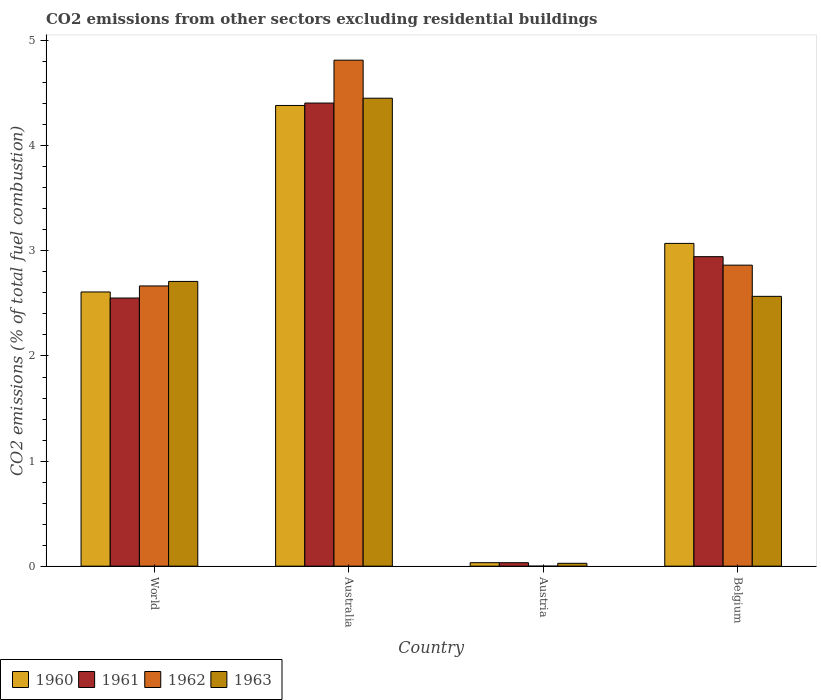Are the number of bars per tick equal to the number of legend labels?
Offer a very short reply. No. How many bars are there on the 3rd tick from the right?
Provide a succinct answer. 4. What is the total CO2 emitted in 1961 in Belgium?
Offer a very short reply. 2.95. Across all countries, what is the maximum total CO2 emitted in 1961?
Ensure brevity in your answer.  4.41. What is the total total CO2 emitted in 1961 in the graph?
Keep it short and to the point. 9.94. What is the difference between the total CO2 emitted in 1960 in Austria and that in Belgium?
Provide a succinct answer. -3.04. What is the difference between the total CO2 emitted in 1963 in World and the total CO2 emitted in 1961 in Belgium?
Offer a very short reply. -0.24. What is the average total CO2 emitted in 1963 per country?
Offer a terse response. 2.44. What is the difference between the total CO2 emitted of/in 1963 and total CO2 emitted of/in 1960 in Belgium?
Ensure brevity in your answer.  -0.5. In how many countries, is the total CO2 emitted in 1963 greater than 4.8?
Make the answer very short. 0. What is the ratio of the total CO2 emitted in 1961 in Australia to that in Austria?
Your answer should be very brief. 133.62. Is the total CO2 emitted in 1960 in Belgium less than that in World?
Your answer should be compact. No. What is the difference between the highest and the second highest total CO2 emitted in 1960?
Provide a succinct answer. -0.46. What is the difference between the highest and the lowest total CO2 emitted in 1962?
Keep it short and to the point. 4.82. How many bars are there?
Your answer should be compact. 15. Are all the bars in the graph horizontal?
Offer a very short reply. No. Are the values on the major ticks of Y-axis written in scientific E-notation?
Offer a terse response. No. Does the graph contain grids?
Offer a terse response. No. How many legend labels are there?
Your response must be concise. 4. What is the title of the graph?
Offer a very short reply. CO2 emissions from other sectors excluding residential buildings. What is the label or title of the Y-axis?
Provide a short and direct response. CO2 emissions (% of total fuel combustion). What is the CO2 emissions (% of total fuel combustion) in 1960 in World?
Provide a succinct answer. 2.61. What is the CO2 emissions (% of total fuel combustion) in 1961 in World?
Keep it short and to the point. 2.55. What is the CO2 emissions (% of total fuel combustion) of 1962 in World?
Keep it short and to the point. 2.67. What is the CO2 emissions (% of total fuel combustion) in 1963 in World?
Your answer should be very brief. 2.71. What is the CO2 emissions (% of total fuel combustion) in 1960 in Australia?
Offer a terse response. 4.38. What is the CO2 emissions (% of total fuel combustion) in 1961 in Australia?
Your response must be concise. 4.41. What is the CO2 emissions (% of total fuel combustion) of 1962 in Australia?
Keep it short and to the point. 4.82. What is the CO2 emissions (% of total fuel combustion) in 1963 in Australia?
Your answer should be very brief. 4.45. What is the CO2 emissions (% of total fuel combustion) in 1960 in Austria?
Offer a terse response. 0.03. What is the CO2 emissions (% of total fuel combustion) of 1961 in Austria?
Offer a very short reply. 0.03. What is the CO2 emissions (% of total fuel combustion) of 1962 in Austria?
Your response must be concise. 0. What is the CO2 emissions (% of total fuel combustion) of 1963 in Austria?
Your response must be concise. 0.03. What is the CO2 emissions (% of total fuel combustion) of 1960 in Belgium?
Your answer should be compact. 3.07. What is the CO2 emissions (% of total fuel combustion) of 1961 in Belgium?
Offer a very short reply. 2.95. What is the CO2 emissions (% of total fuel combustion) of 1962 in Belgium?
Provide a succinct answer. 2.86. What is the CO2 emissions (% of total fuel combustion) of 1963 in Belgium?
Your response must be concise. 2.57. Across all countries, what is the maximum CO2 emissions (% of total fuel combustion) in 1960?
Ensure brevity in your answer.  4.38. Across all countries, what is the maximum CO2 emissions (% of total fuel combustion) of 1961?
Make the answer very short. 4.41. Across all countries, what is the maximum CO2 emissions (% of total fuel combustion) in 1962?
Provide a succinct answer. 4.82. Across all countries, what is the maximum CO2 emissions (% of total fuel combustion) in 1963?
Offer a terse response. 4.45. Across all countries, what is the minimum CO2 emissions (% of total fuel combustion) of 1960?
Your answer should be very brief. 0.03. Across all countries, what is the minimum CO2 emissions (% of total fuel combustion) in 1961?
Keep it short and to the point. 0.03. Across all countries, what is the minimum CO2 emissions (% of total fuel combustion) in 1962?
Make the answer very short. 0. Across all countries, what is the minimum CO2 emissions (% of total fuel combustion) of 1963?
Make the answer very short. 0.03. What is the total CO2 emissions (% of total fuel combustion) in 1960 in the graph?
Your response must be concise. 10.1. What is the total CO2 emissions (% of total fuel combustion) in 1961 in the graph?
Provide a short and direct response. 9.94. What is the total CO2 emissions (% of total fuel combustion) in 1962 in the graph?
Keep it short and to the point. 10.35. What is the total CO2 emissions (% of total fuel combustion) of 1963 in the graph?
Make the answer very short. 9.76. What is the difference between the CO2 emissions (% of total fuel combustion) of 1960 in World and that in Australia?
Ensure brevity in your answer.  -1.77. What is the difference between the CO2 emissions (% of total fuel combustion) of 1961 in World and that in Australia?
Your response must be concise. -1.86. What is the difference between the CO2 emissions (% of total fuel combustion) in 1962 in World and that in Australia?
Provide a succinct answer. -2.15. What is the difference between the CO2 emissions (% of total fuel combustion) in 1963 in World and that in Australia?
Ensure brevity in your answer.  -1.74. What is the difference between the CO2 emissions (% of total fuel combustion) in 1960 in World and that in Austria?
Make the answer very short. 2.58. What is the difference between the CO2 emissions (% of total fuel combustion) of 1961 in World and that in Austria?
Provide a short and direct response. 2.52. What is the difference between the CO2 emissions (% of total fuel combustion) of 1963 in World and that in Austria?
Your answer should be very brief. 2.68. What is the difference between the CO2 emissions (% of total fuel combustion) in 1960 in World and that in Belgium?
Your answer should be compact. -0.46. What is the difference between the CO2 emissions (% of total fuel combustion) of 1961 in World and that in Belgium?
Offer a terse response. -0.39. What is the difference between the CO2 emissions (% of total fuel combustion) of 1962 in World and that in Belgium?
Ensure brevity in your answer.  -0.2. What is the difference between the CO2 emissions (% of total fuel combustion) of 1963 in World and that in Belgium?
Provide a short and direct response. 0.14. What is the difference between the CO2 emissions (% of total fuel combustion) in 1960 in Australia and that in Austria?
Provide a short and direct response. 4.35. What is the difference between the CO2 emissions (% of total fuel combustion) in 1961 in Australia and that in Austria?
Give a very brief answer. 4.37. What is the difference between the CO2 emissions (% of total fuel combustion) in 1963 in Australia and that in Austria?
Provide a succinct answer. 4.43. What is the difference between the CO2 emissions (% of total fuel combustion) in 1960 in Australia and that in Belgium?
Make the answer very short. 1.31. What is the difference between the CO2 emissions (% of total fuel combustion) of 1961 in Australia and that in Belgium?
Your response must be concise. 1.46. What is the difference between the CO2 emissions (% of total fuel combustion) of 1962 in Australia and that in Belgium?
Offer a very short reply. 1.95. What is the difference between the CO2 emissions (% of total fuel combustion) of 1963 in Australia and that in Belgium?
Provide a short and direct response. 1.89. What is the difference between the CO2 emissions (% of total fuel combustion) of 1960 in Austria and that in Belgium?
Provide a succinct answer. -3.04. What is the difference between the CO2 emissions (% of total fuel combustion) in 1961 in Austria and that in Belgium?
Provide a short and direct response. -2.91. What is the difference between the CO2 emissions (% of total fuel combustion) of 1963 in Austria and that in Belgium?
Provide a succinct answer. -2.54. What is the difference between the CO2 emissions (% of total fuel combustion) in 1960 in World and the CO2 emissions (% of total fuel combustion) in 1961 in Australia?
Your response must be concise. -1.8. What is the difference between the CO2 emissions (% of total fuel combustion) in 1960 in World and the CO2 emissions (% of total fuel combustion) in 1962 in Australia?
Your answer should be compact. -2.21. What is the difference between the CO2 emissions (% of total fuel combustion) in 1960 in World and the CO2 emissions (% of total fuel combustion) in 1963 in Australia?
Your answer should be compact. -1.84. What is the difference between the CO2 emissions (% of total fuel combustion) of 1961 in World and the CO2 emissions (% of total fuel combustion) of 1962 in Australia?
Your answer should be compact. -2.26. What is the difference between the CO2 emissions (% of total fuel combustion) of 1961 in World and the CO2 emissions (% of total fuel combustion) of 1963 in Australia?
Make the answer very short. -1.9. What is the difference between the CO2 emissions (% of total fuel combustion) in 1962 in World and the CO2 emissions (% of total fuel combustion) in 1963 in Australia?
Offer a very short reply. -1.79. What is the difference between the CO2 emissions (% of total fuel combustion) of 1960 in World and the CO2 emissions (% of total fuel combustion) of 1961 in Austria?
Give a very brief answer. 2.58. What is the difference between the CO2 emissions (% of total fuel combustion) in 1960 in World and the CO2 emissions (% of total fuel combustion) in 1963 in Austria?
Your answer should be compact. 2.58. What is the difference between the CO2 emissions (% of total fuel combustion) of 1961 in World and the CO2 emissions (% of total fuel combustion) of 1963 in Austria?
Provide a succinct answer. 2.52. What is the difference between the CO2 emissions (% of total fuel combustion) of 1962 in World and the CO2 emissions (% of total fuel combustion) of 1963 in Austria?
Ensure brevity in your answer.  2.64. What is the difference between the CO2 emissions (% of total fuel combustion) in 1960 in World and the CO2 emissions (% of total fuel combustion) in 1961 in Belgium?
Offer a very short reply. -0.34. What is the difference between the CO2 emissions (% of total fuel combustion) in 1960 in World and the CO2 emissions (% of total fuel combustion) in 1962 in Belgium?
Provide a short and direct response. -0.26. What is the difference between the CO2 emissions (% of total fuel combustion) in 1960 in World and the CO2 emissions (% of total fuel combustion) in 1963 in Belgium?
Your response must be concise. 0.04. What is the difference between the CO2 emissions (% of total fuel combustion) of 1961 in World and the CO2 emissions (% of total fuel combustion) of 1962 in Belgium?
Offer a terse response. -0.31. What is the difference between the CO2 emissions (% of total fuel combustion) of 1961 in World and the CO2 emissions (% of total fuel combustion) of 1963 in Belgium?
Provide a short and direct response. -0.02. What is the difference between the CO2 emissions (% of total fuel combustion) of 1962 in World and the CO2 emissions (% of total fuel combustion) of 1963 in Belgium?
Make the answer very short. 0.1. What is the difference between the CO2 emissions (% of total fuel combustion) of 1960 in Australia and the CO2 emissions (% of total fuel combustion) of 1961 in Austria?
Provide a short and direct response. 4.35. What is the difference between the CO2 emissions (% of total fuel combustion) in 1960 in Australia and the CO2 emissions (% of total fuel combustion) in 1963 in Austria?
Make the answer very short. 4.36. What is the difference between the CO2 emissions (% of total fuel combustion) in 1961 in Australia and the CO2 emissions (% of total fuel combustion) in 1963 in Austria?
Provide a short and direct response. 4.38. What is the difference between the CO2 emissions (% of total fuel combustion) of 1962 in Australia and the CO2 emissions (% of total fuel combustion) of 1963 in Austria?
Your answer should be compact. 4.79. What is the difference between the CO2 emissions (% of total fuel combustion) in 1960 in Australia and the CO2 emissions (% of total fuel combustion) in 1961 in Belgium?
Keep it short and to the point. 1.44. What is the difference between the CO2 emissions (% of total fuel combustion) of 1960 in Australia and the CO2 emissions (% of total fuel combustion) of 1962 in Belgium?
Provide a short and direct response. 1.52. What is the difference between the CO2 emissions (% of total fuel combustion) of 1960 in Australia and the CO2 emissions (% of total fuel combustion) of 1963 in Belgium?
Keep it short and to the point. 1.82. What is the difference between the CO2 emissions (% of total fuel combustion) of 1961 in Australia and the CO2 emissions (% of total fuel combustion) of 1962 in Belgium?
Provide a succinct answer. 1.54. What is the difference between the CO2 emissions (% of total fuel combustion) of 1961 in Australia and the CO2 emissions (% of total fuel combustion) of 1963 in Belgium?
Offer a very short reply. 1.84. What is the difference between the CO2 emissions (% of total fuel combustion) of 1962 in Australia and the CO2 emissions (% of total fuel combustion) of 1963 in Belgium?
Offer a very short reply. 2.25. What is the difference between the CO2 emissions (% of total fuel combustion) of 1960 in Austria and the CO2 emissions (% of total fuel combustion) of 1961 in Belgium?
Your answer should be compact. -2.91. What is the difference between the CO2 emissions (% of total fuel combustion) in 1960 in Austria and the CO2 emissions (% of total fuel combustion) in 1962 in Belgium?
Make the answer very short. -2.83. What is the difference between the CO2 emissions (% of total fuel combustion) of 1960 in Austria and the CO2 emissions (% of total fuel combustion) of 1963 in Belgium?
Ensure brevity in your answer.  -2.53. What is the difference between the CO2 emissions (% of total fuel combustion) in 1961 in Austria and the CO2 emissions (% of total fuel combustion) in 1962 in Belgium?
Ensure brevity in your answer.  -2.83. What is the difference between the CO2 emissions (% of total fuel combustion) in 1961 in Austria and the CO2 emissions (% of total fuel combustion) in 1963 in Belgium?
Your answer should be compact. -2.53. What is the average CO2 emissions (% of total fuel combustion) in 1960 per country?
Offer a terse response. 2.52. What is the average CO2 emissions (% of total fuel combustion) of 1961 per country?
Keep it short and to the point. 2.48. What is the average CO2 emissions (% of total fuel combustion) in 1962 per country?
Keep it short and to the point. 2.59. What is the average CO2 emissions (% of total fuel combustion) in 1963 per country?
Give a very brief answer. 2.44. What is the difference between the CO2 emissions (% of total fuel combustion) of 1960 and CO2 emissions (% of total fuel combustion) of 1961 in World?
Provide a succinct answer. 0.06. What is the difference between the CO2 emissions (% of total fuel combustion) in 1960 and CO2 emissions (% of total fuel combustion) in 1962 in World?
Offer a very short reply. -0.06. What is the difference between the CO2 emissions (% of total fuel combustion) of 1960 and CO2 emissions (% of total fuel combustion) of 1963 in World?
Make the answer very short. -0.1. What is the difference between the CO2 emissions (% of total fuel combustion) in 1961 and CO2 emissions (% of total fuel combustion) in 1962 in World?
Provide a short and direct response. -0.12. What is the difference between the CO2 emissions (% of total fuel combustion) of 1961 and CO2 emissions (% of total fuel combustion) of 1963 in World?
Ensure brevity in your answer.  -0.16. What is the difference between the CO2 emissions (% of total fuel combustion) in 1962 and CO2 emissions (% of total fuel combustion) in 1963 in World?
Provide a succinct answer. -0.04. What is the difference between the CO2 emissions (% of total fuel combustion) in 1960 and CO2 emissions (% of total fuel combustion) in 1961 in Australia?
Ensure brevity in your answer.  -0.02. What is the difference between the CO2 emissions (% of total fuel combustion) in 1960 and CO2 emissions (% of total fuel combustion) in 1962 in Australia?
Your response must be concise. -0.43. What is the difference between the CO2 emissions (% of total fuel combustion) of 1960 and CO2 emissions (% of total fuel combustion) of 1963 in Australia?
Keep it short and to the point. -0.07. What is the difference between the CO2 emissions (% of total fuel combustion) of 1961 and CO2 emissions (% of total fuel combustion) of 1962 in Australia?
Your answer should be compact. -0.41. What is the difference between the CO2 emissions (% of total fuel combustion) of 1961 and CO2 emissions (% of total fuel combustion) of 1963 in Australia?
Offer a very short reply. -0.05. What is the difference between the CO2 emissions (% of total fuel combustion) in 1962 and CO2 emissions (% of total fuel combustion) in 1963 in Australia?
Keep it short and to the point. 0.36. What is the difference between the CO2 emissions (% of total fuel combustion) of 1960 and CO2 emissions (% of total fuel combustion) of 1961 in Austria?
Provide a short and direct response. 0. What is the difference between the CO2 emissions (% of total fuel combustion) of 1960 and CO2 emissions (% of total fuel combustion) of 1963 in Austria?
Keep it short and to the point. 0.01. What is the difference between the CO2 emissions (% of total fuel combustion) in 1961 and CO2 emissions (% of total fuel combustion) in 1963 in Austria?
Offer a terse response. 0.01. What is the difference between the CO2 emissions (% of total fuel combustion) of 1960 and CO2 emissions (% of total fuel combustion) of 1961 in Belgium?
Ensure brevity in your answer.  0.13. What is the difference between the CO2 emissions (% of total fuel combustion) in 1960 and CO2 emissions (% of total fuel combustion) in 1962 in Belgium?
Keep it short and to the point. 0.21. What is the difference between the CO2 emissions (% of total fuel combustion) of 1960 and CO2 emissions (% of total fuel combustion) of 1963 in Belgium?
Your response must be concise. 0.5. What is the difference between the CO2 emissions (% of total fuel combustion) in 1961 and CO2 emissions (% of total fuel combustion) in 1962 in Belgium?
Ensure brevity in your answer.  0.08. What is the difference between the CO2 emissions (% of total fuel combustion) of 1961 and CO2 emissions (% of total fuel combustion) of 1963 in Belgium?
Your answer should be very brief. 0.38. What is the difference between the CO2 emissions (% of total fuel combustion) of 1962 and CO2 emissions (% of total fuel combustion) of 1963 in Belgium?
Offer a very short reply. 0.3. What is the ratio of the CO2 emissions (% of total fuel combustion) in 1960 in World to that in Australia?
Provide a short and direct response. 0.6. What is the ratio of the CO2 emissions (% of total fuel combustion) in 1961 in World to that in Australia?
Provide a succinct answer. 0.58. What is the ratio of the CO2 emissions (% of total fuel combustion) of 1962 in World to that in Australia?
Make the answer very short. 0.55. What is the ratio of the CO2 emissions (% of total fuel combustion) in 1963 in World to that in Australia?
Offer a terse response. 0.61. What is the ratio of the CO2 emissions (% of total fuel combustion) of 1960 in World to that in Austria?
Ensure brevity in your answer.  78.47. What is the ratio of the CO2 emissions (% of total fuel combustion) of 1961 in World to that in Austria?
Ensure brevity in your answer.  77.37. What is the ratio of the CO2 emissions (% of total fuel combustion) of 1963 in World to that in Austria?
Ensure brevity in your answer.  99.22. What is the ratio of the CO2 emissions (% of total fuel combustion) of 1960 in World to that in Belgium?
Offer a very short reply. 0.85. What is the ratio of the CO2 emissions (% of total fuel combustion) of 1961 in World to that in Belgium?
Give a very brief answer. 0.87. What is the ratio of the CO2 emissions (% of total fuel combustion) in 1962 in World to that in Belgium?
Make the answer very short. 0.93. What is the ratio of the CO2 emissions (% of total fuel combustion) in 1963 in World to that in Belgium?
Provide a short and direct response. 1.06. What is the ratio of the CO2 emissions (% of total fuel combustion) in 1960 in Australia to that in Austria?
Make the answer very short. 131.83. What is the ratio of the CO2 emissions (% of total fuel combustion) of 1961 in Australia to that in Austria?
Your response must be concise. 133.62. What is the ratio of the CO2 emissions (% of total fuel combustion) of 1963 in Australia to that in Austria?
Make the answer very short. 163.07. What is the ratio of the CO2 emissions (% of total fuel combustion) of 1960 in Australia to that in Belgium?
Ensure brevity in your answer.  1.43. What is the ratio of the CO2 emissions (% of total fuel combustion) of 1961 in Australia to that in Belgium?
Ensure brevity in your answer.  1.5. What is the ratio of the CO2 emissions (% of total fuel combustion) of 1962 in Australia to that in Belgium?
Make the answer very short. 1.68. What is the ratio of the CO2 emissions (% of total fuel combustion) of 1963 in Australia to that in Belgium?
Your answer should be very brief. 1.73. What is the ratio of the CO2 emissions (% of total fuel combustion) of 1960 in Austria to that in Belgium?
Your response must be concise. 0.01. What is the ratio of the CO2 emissions (% of total fuel combustion) of 1961 in Austria to that in Belgium?
Provide a succinct answer. 0.01. What is the ratio of the CO2 emissions (% of total fuel combustion) of 1963 in Austria to that in Belgium?
Provide a short and direct response. 0.01. What is the difference between the highest and the second highest CO2 emissions (% of total fuel combustion) in 1960?
Give a very brief answer. 1.31. What is the difference between the highest and the second highest CO2 emissions (% of total fuel combustion) of 1961?
Ensure brevity in your answer.  1.46. What is the difference between the highest and the second highest CO2 emissions (% of total fuel combustion) of 1962?
Your answer should be compact. 1.95. What is the difference between the highest and the second highest CO2 emissions (% of total fuel combustion) of 1963?
Your response must be concise. 1.74. What is the difference between the highest and the lowest CO2 emissions (% of total fuel combustion) in 1960?
Your response must be concise. 4.35. What is the difference between the highest and the lowest CO2 emissions (% of total fuel combustion) in 1961?
Your answer should be compact. 4.37. What is the difference between the highest and the lowest CO2 emissions (% of total fuel combustion) in 1962?
Provide a succinct answer. 4.82. What is the difference between the highest and the lowest CO2 emissions (% of total fuel combustion) in 1963?
Offer a very short reply. 4.43. 